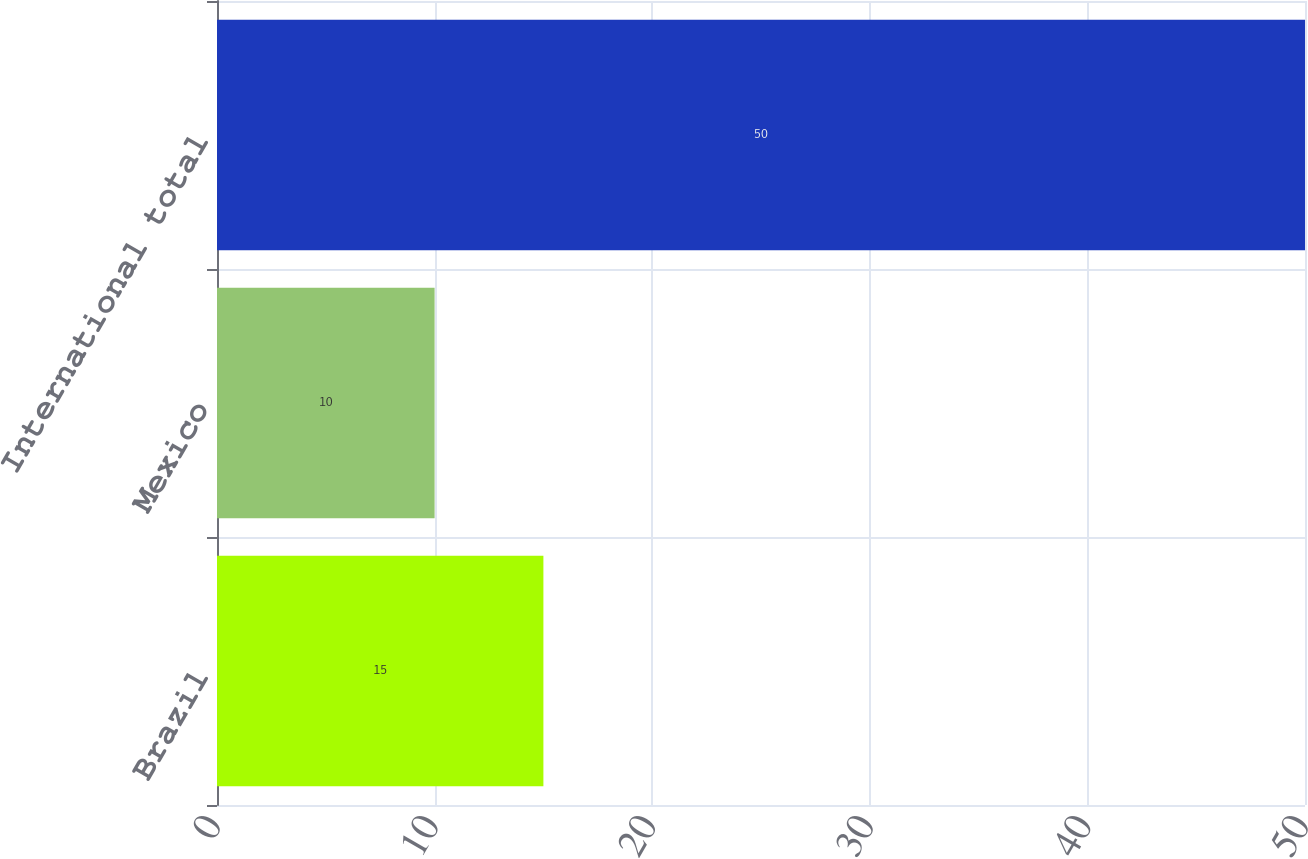Convert chart. <chart><loc_0><loc_0><loc_500><loc_500><bar_chart><fcel>Brazil<fcel>Mexico<fcel>International total<nl><fcel>15<fcel>10<fcel>50<nl></chart> 